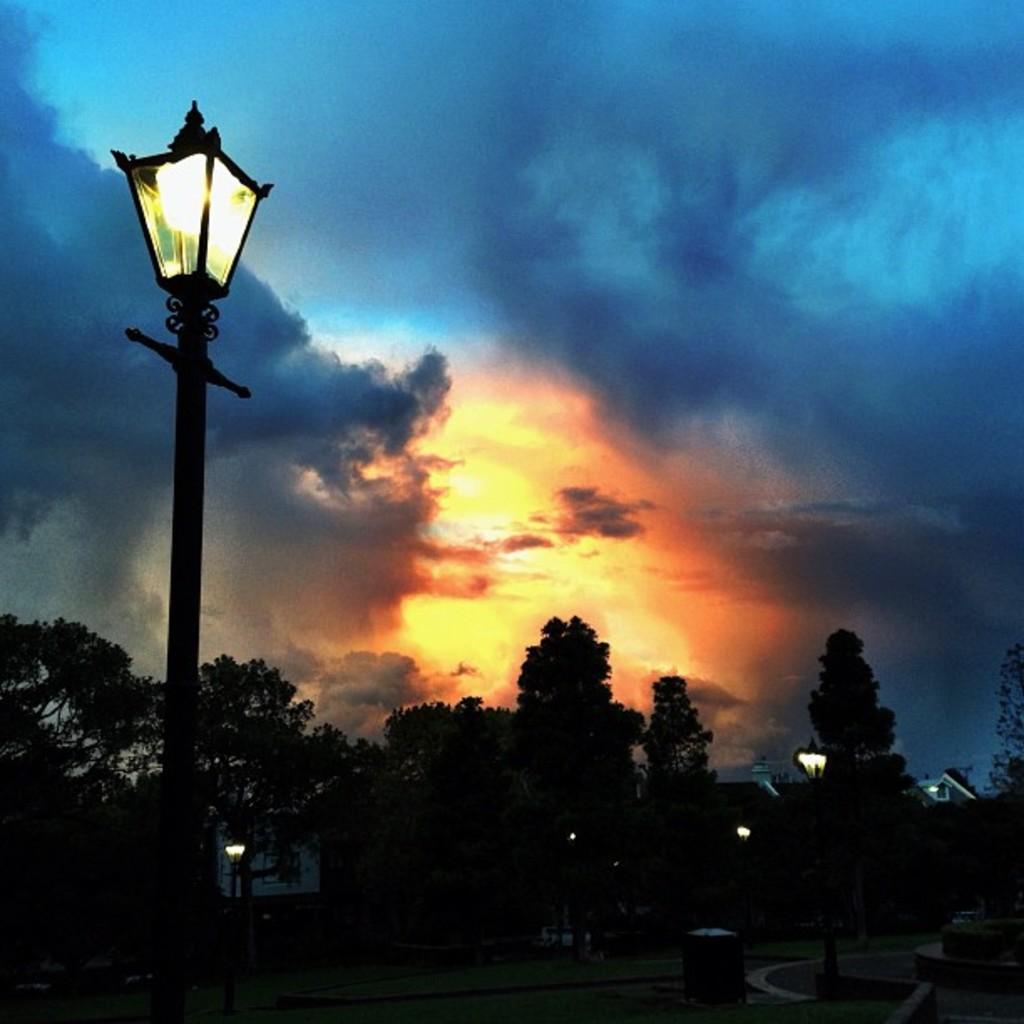Please provide a concise description of this image. In this picture we can see trees,poles and we can see sky in the background. 